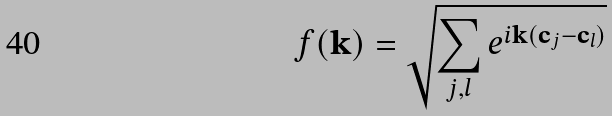Convert formula to latex. <formula><loc_0><loc_0><loc_500><loc_500>f ( { \mathbf k } ) = \sqrt { \sum _ { j , l } e ^ { i { \mathbf k } ( { \mathbf c } _ { j } - { \mathbf c } _ { l } ) } }</formula> 